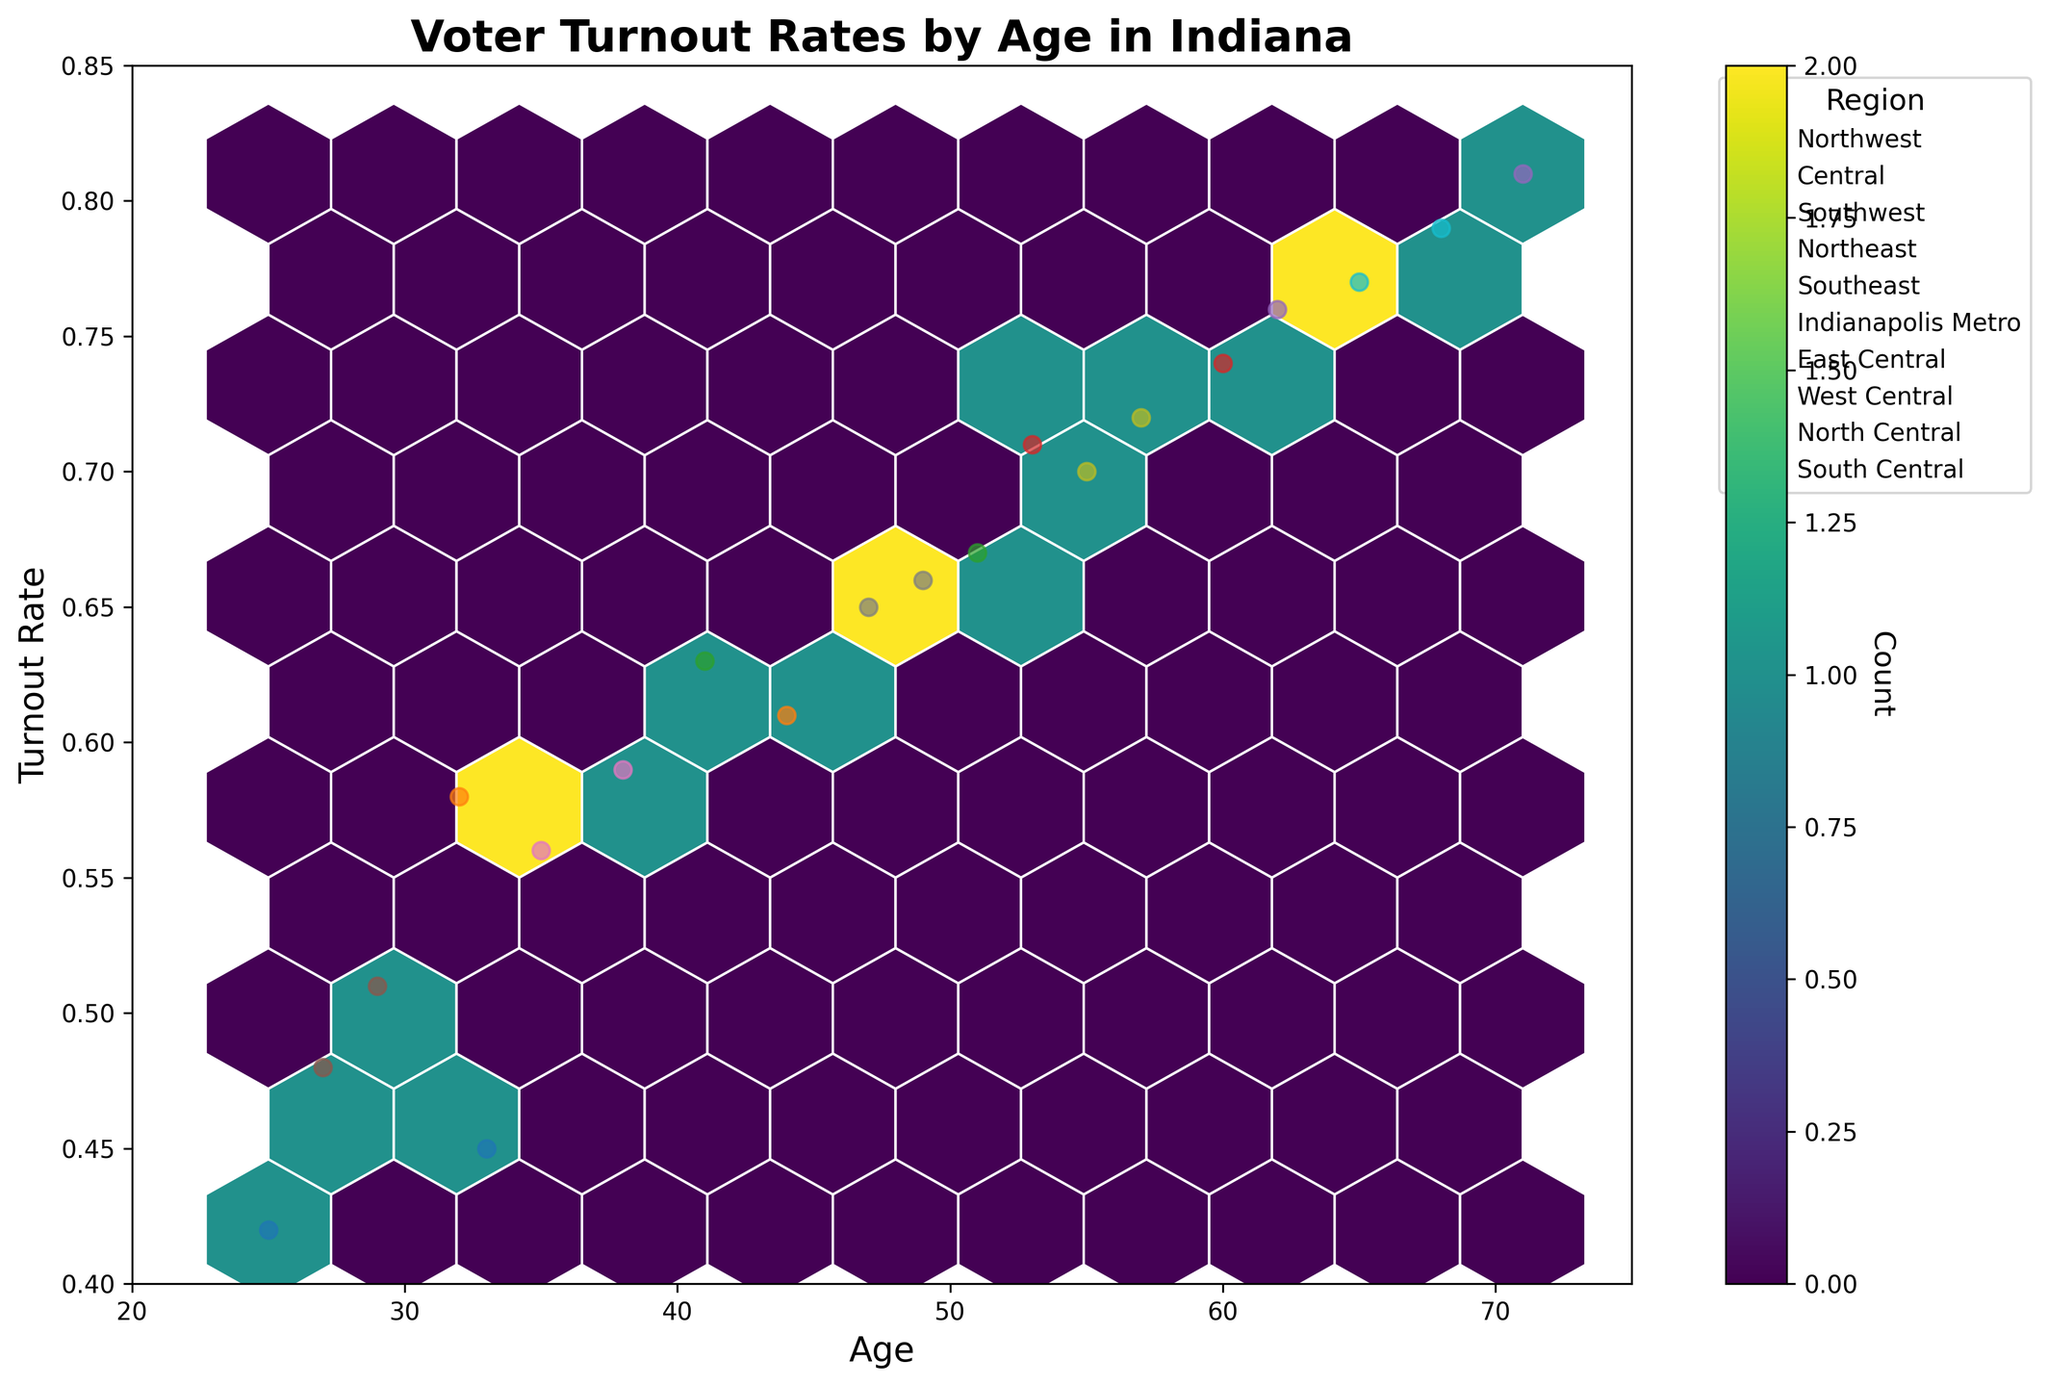What's the title of the plot? The title of the plot is found at the top center of the plot area and is usually in a larger and bolder font than other text elements. It provides a summary of what the plot represents. In this case, it should be readily visible and clearly describe the subject of the plot.
Answer: Voter Turnout Rates by Age in Indiana What do the x and y axes represent? The x-axis represents the variable plotted along the horizontal direction, while the y-axis represents the variable plotted vertically. Looking at the figure, the labels at the ends of the axes indicate their respective variables.
Answer: Age and Turnout Rate Between what ages is the data plotted? To determine the range of ages, one would look at the limits of the x-axis, which shows the smallest and largest ages represented in the dataset. The plot typically has tick marks or labels indicating these numbers.
Answer: 20 to 75 What is the color of the hexagons in the plot? The color of the hexagons in the hexbin plot is determined by the color map used, which can be seen in the plot's legend or just by observing the plot. Each hexagon's color reflects data density, varying in shades according to the color map.
Answer: Shades of viridis Which region has the highest voter turnout rate for the oldest age group shown? To answer this, locate the points representing the highest ages on the x-axis, then find the regions of these points by looking at the legend or directly checking the respective points. The highest turnout rate in the region for these points can be identified using the y-axis.
Answer: Southeast How many unique regions are represented in this plot? By examining the legend on the plot, which lists the categories (regions) depicted, one can count the number of unique labels present. Each label corresponds to a distinct region.
Answer: 9 Which region shows the lowest voter turnout rate, and what is that rate? To find the lowest turnout rate, one would scan the data points (or hexagons, if distinct), typically positioned around the y-axis's lower limit. Then identify the corresponding region using the legend or point markers.
Answer: Northwest, 0.42 Do older age groups generally have higher voter turnout rates than younger age groups? To answer this, observe the trend of the data points along the x-axis (from younger to older ages) and note if the points' y-values (turnout rates) tend to increase. This analysis may involve looking at the overall spread and direction of data points' clustering.
Answer: Yes What is the approximate median voter turnout rate for all age groups combined? The median is found by arranging the turnout rates in order and finding the middle value. In plots, this often means identifying the central point in terms of density or using the hexbin plot's color distribution around the median area on the y-axis.
Answer: Approximately 0.65 